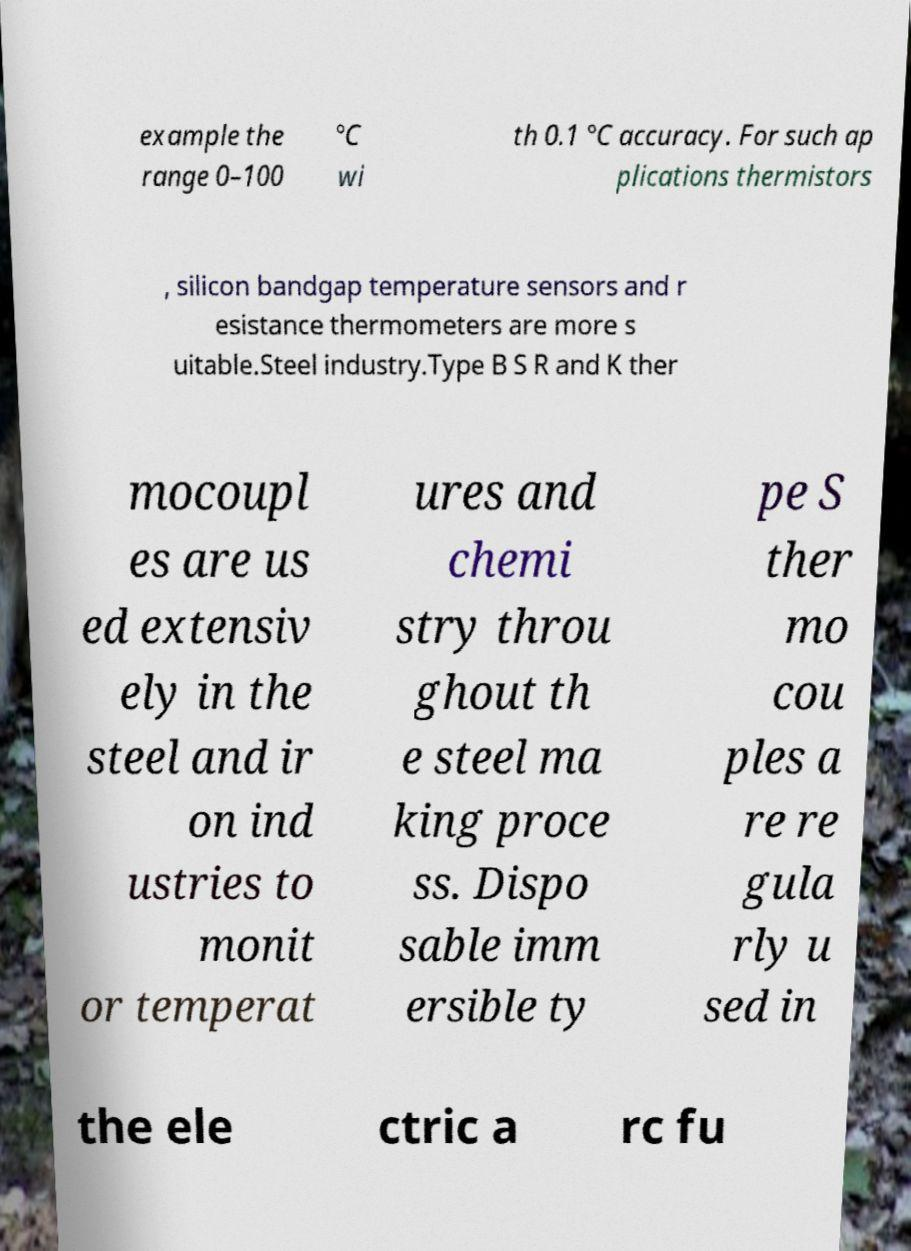What messages or text are displayed in this image? I need them in a readable, typed format. example the range 0–100 °C wi th 0.1 °C accuracy. For such ap plications thermistors , silicon bandgap temperature sensors and r esistance thermometers are more s uitable.Steel industry.Type B S R and K ther mocoupl es are us ed extensiv ely in the steel and ir on ind ustries to monit or temperat ures and chemi stry throu ghout th e steel ma king proce ss. Dispo sable imm ersible ty pe S ther mo cou ples a re re gula rly u sed in the ele ctric a rc fu 